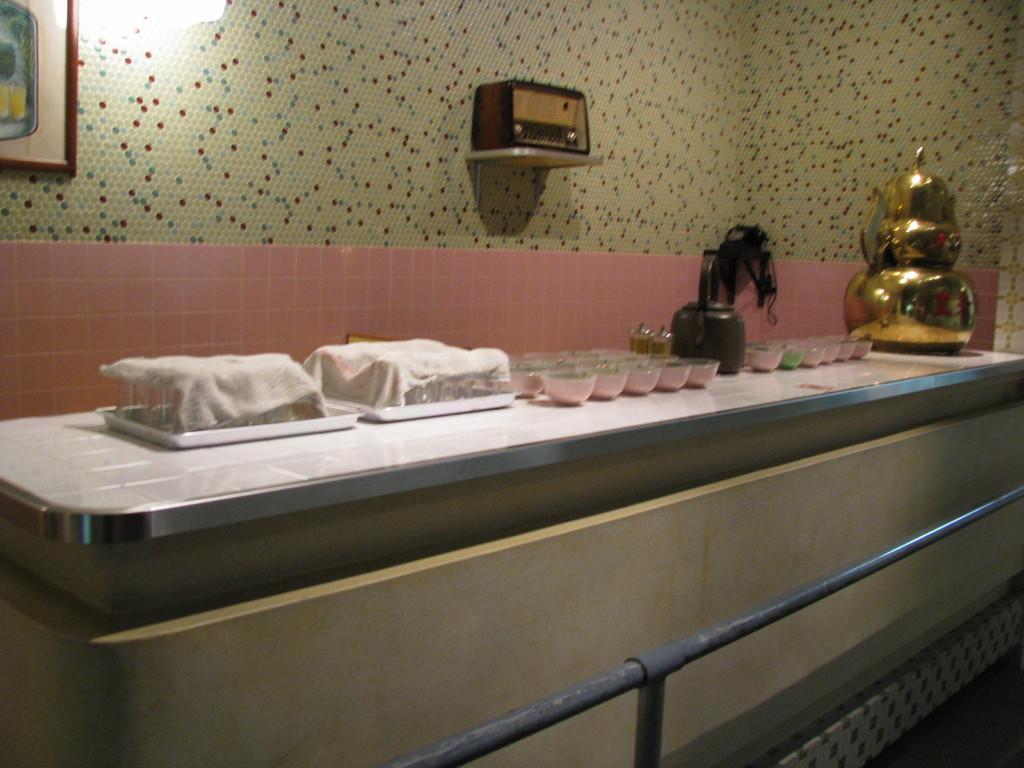Please provide a concise description of this image. In this image we can see some objects on the table containing some bowls, a container, a kettle and some glasses in the trays covered with the napkins. On the bottom of the image we can see a metal pole. On the backside we can see a device on a rack, a light and a photo frame on a wall. 